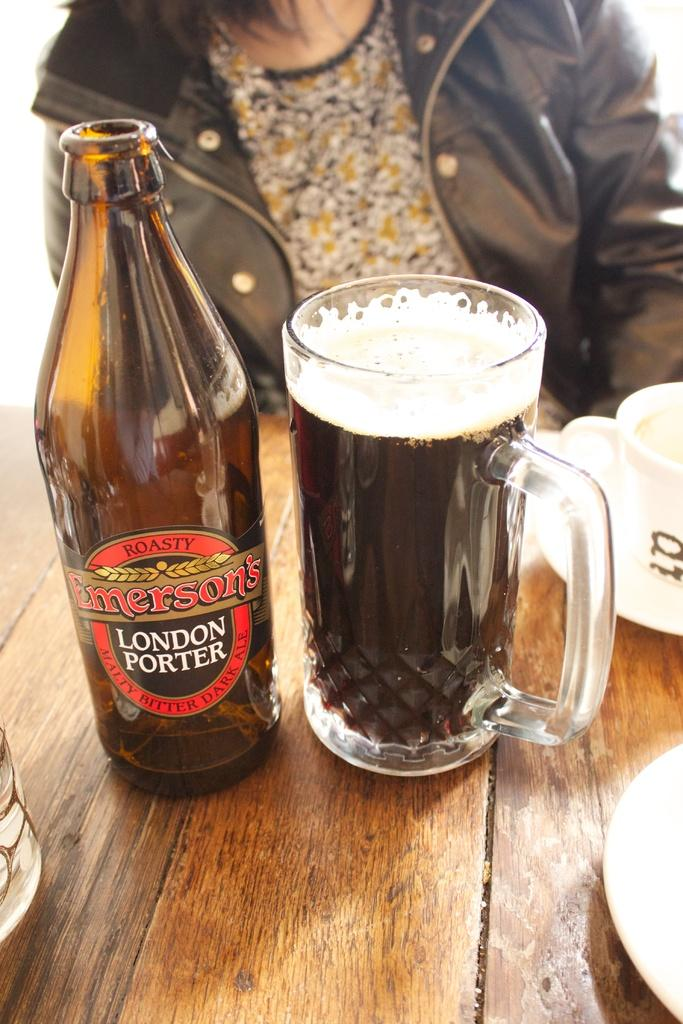What type of container is visible in the image? There is a bottle and a glass in the image. Can you describe any other objects in the image? There is a person and a cup in the background of the image. What type of battle is taking place in the image? There is no battle present in the image; it only features a bottle, a glass, a person, and a cup. 